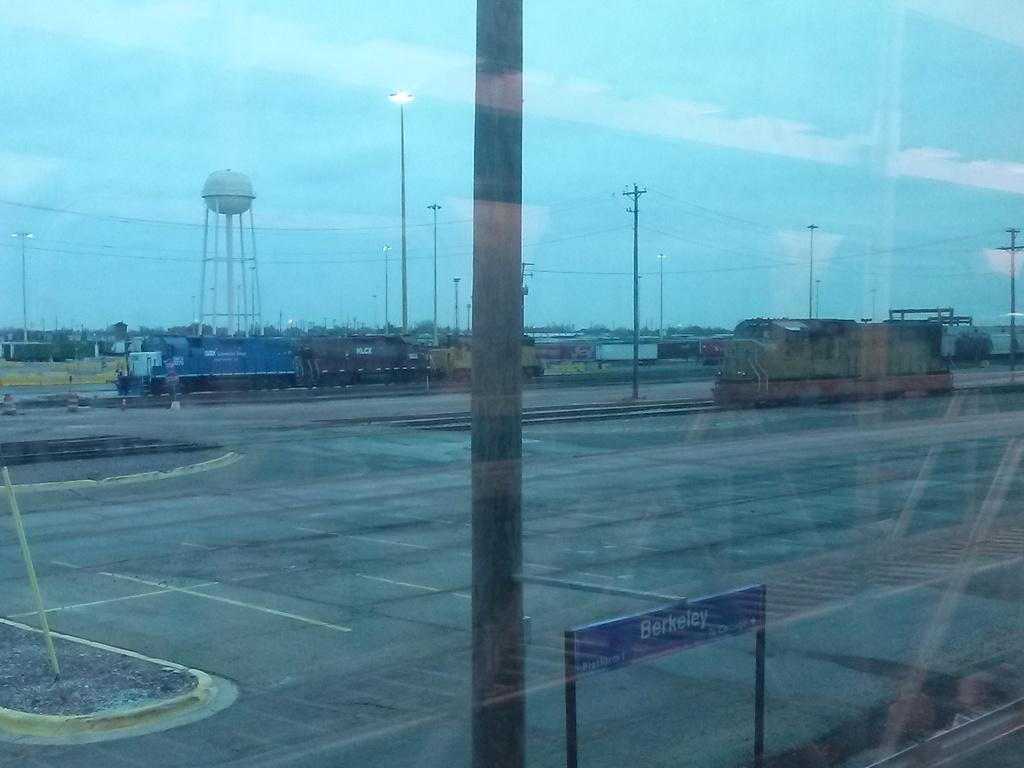<image>
Share a concise interpretation of the image provided. An empty parking lot, with a blue sign in the foreground that says Berkeley. 